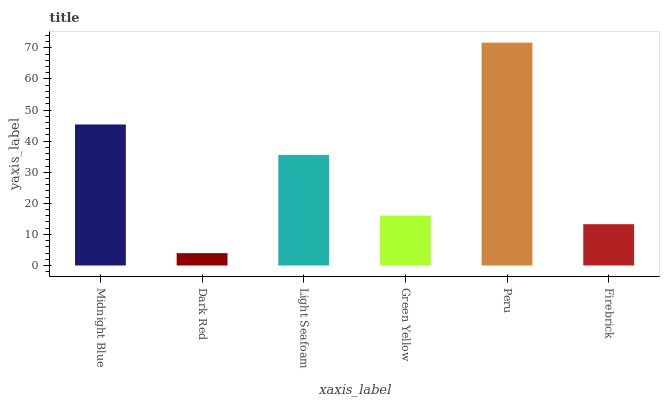Is Dark Red the minimum?
Answer yes or no. Yes. Is Peru the maximum?
Answer yes or no. Yes. Is Light Seafoam the minimum?
Answer yes or no. No. Is Light Seafoam the maximum?
Answer yes or no. No. Is Light Seafoam greater than Dark Red?
Answer yes or no. Yes. Is Dark Red less than Light Seafoam?
Answer yes or no. Yes. Is Dark Red greater than Light Seafoam?
Answer yes or no. No. Is Light Seafoam less than Dark Red?
Answer yes or no. No. Is Light Seafoam the high median?
Answer yes or no. Yes. Is Green Yellow the low median?
Answer yes or no. Yes. Is Midnight Blue the high median?
Answer yes or no. No. Is Light Seafoam the low median?
Answer yes or no. No. 